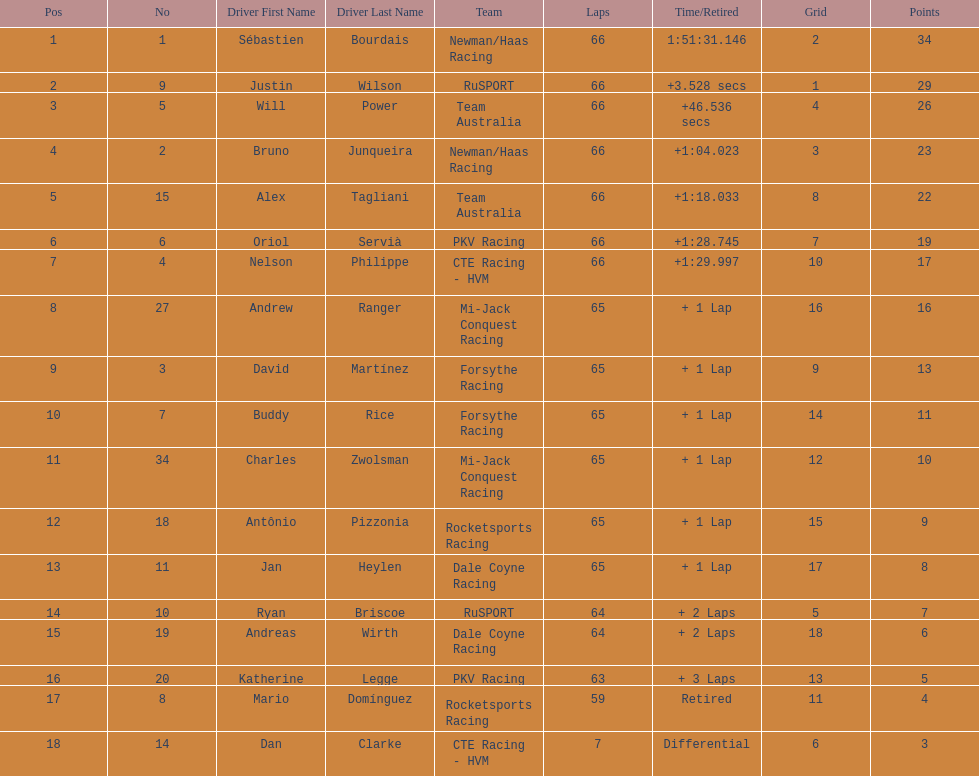Who finished directly after the driver who finished in 1:28.745? Nelson Philippe. 